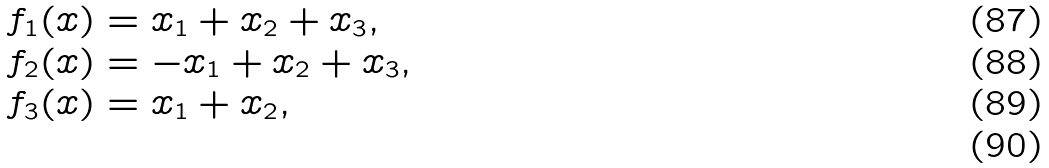Convert formula to latex. <formula><loc_0><loc_0><loc_500><loc_500>f _ { 1 } ( x ) & = x _ { 1 } + x _ { 2 } + x _ { 3 } , \\ f _ { 2 } ( x ) & = - x _ { 1 } + x _ { 2 } + x _ { 3 } , \\ f _ { 3 } ( x ) & = x _ { 1 } + x _ { 2 } , \\</formula> 